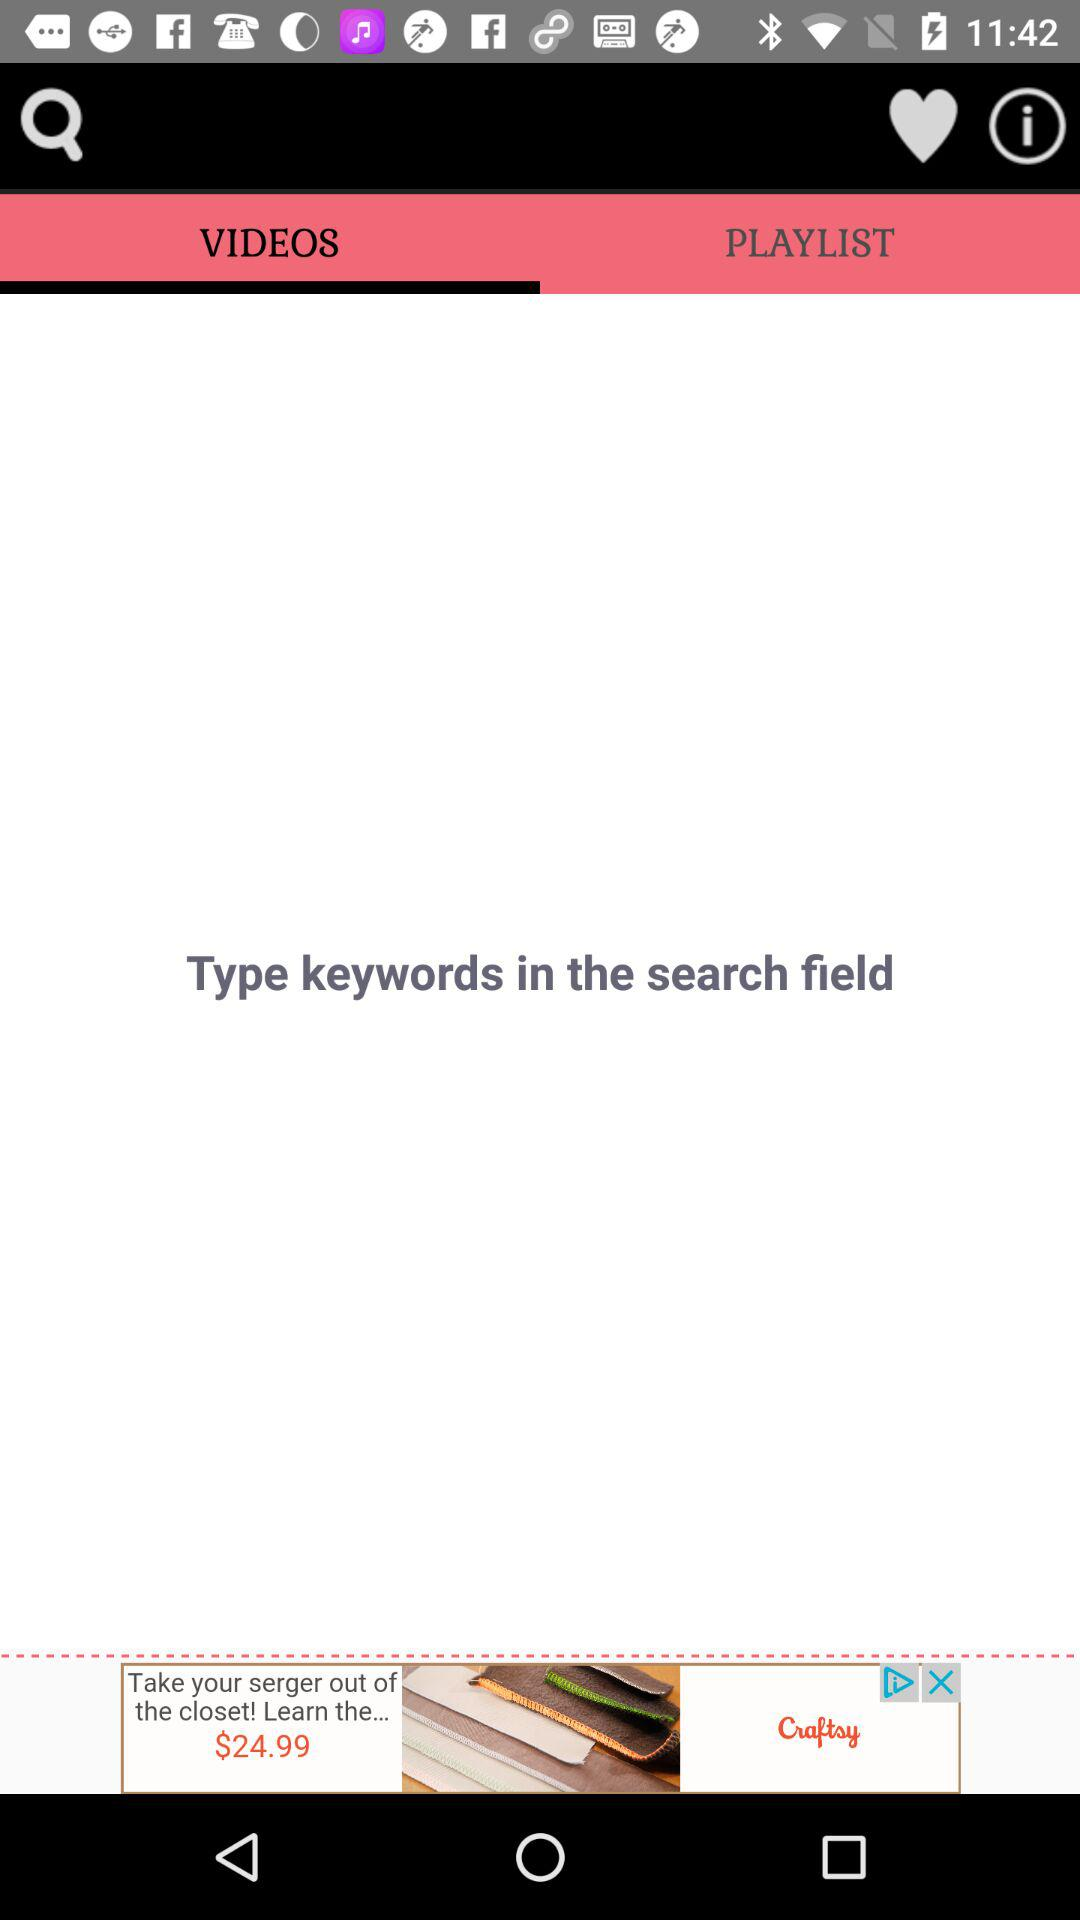Which tab has been selected? The tab that has been selected is "VIDEOS". 